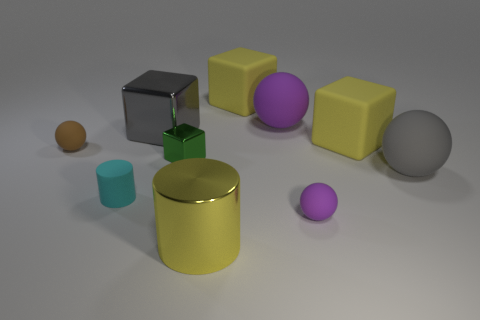Subtract all blue spheres. Subtract all red cubes. How many spheres are left? 4 Subtract all cylinders. How many objects are left? 8 Subtract 0 purple blocks. How many objects are left? 10 Subtract all metal cylinders. Subtract all matte cylinders. How many objects are left? 8 Add 4 tiny blocks. How many tiny blocks are left? 5 Add 9 small shiny cubes. How many small shiny cubes exist? 10 